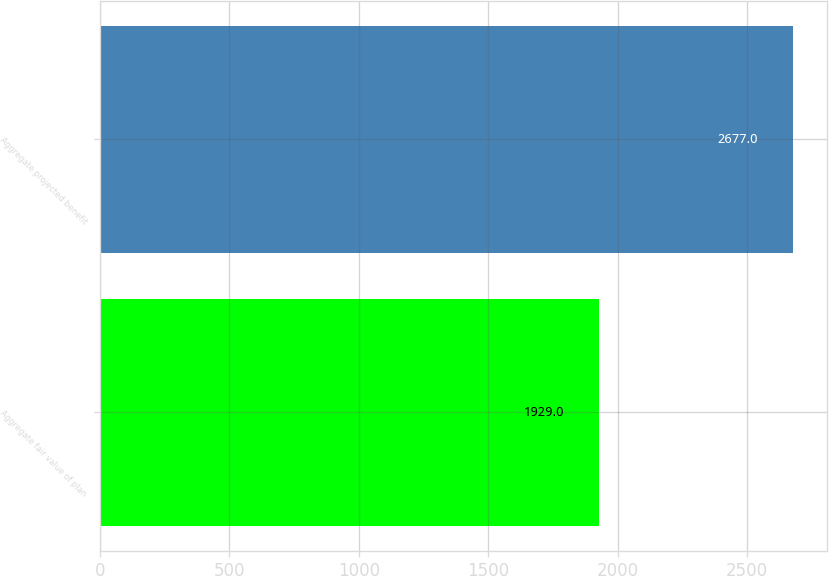Convert chart to OTSL. <chart><loc_0><loc_0><loc_500><loc_500><bar_chart><fcel>Aggregate fair value of plan<fcel>Aggregate projected benefit<nl><fcel>1929<fcel>2677<nl></chart> 